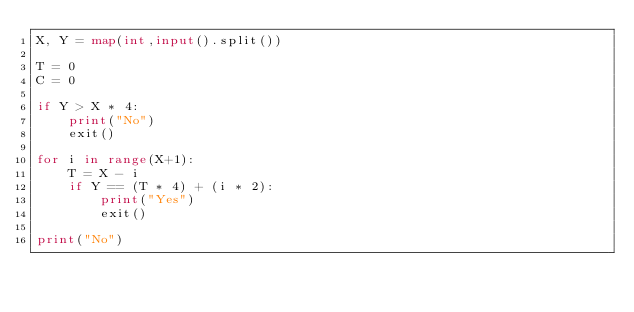Convert code to text. <code><loc_0><loc_0><loc_500><loc_500><_Python_>X, Y = map(int,input().split())

T = 0
C = 0

if Y > X * 4:
    print("No")
    exit()

for i in range(X+1):
    T = X - i
    if Y == (T * 4) + (i * 2):
        print("Yes")
        exit()

print("No")</code> 